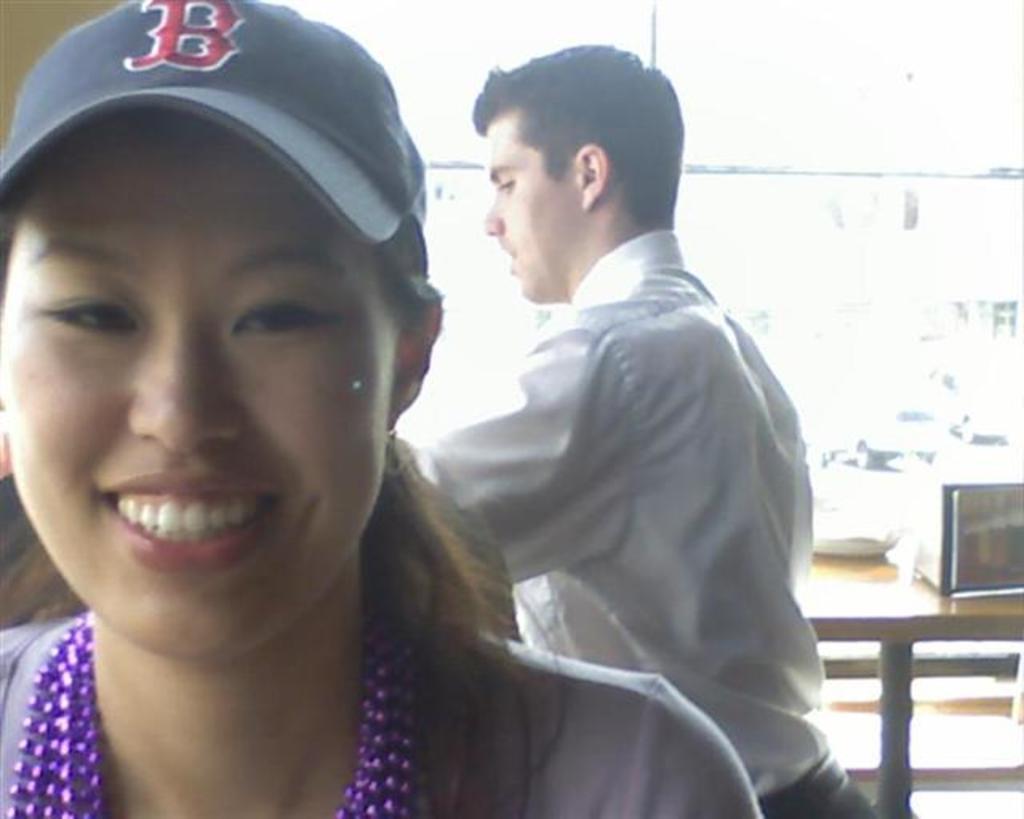What is the letter on the cap?
Your answer should be compact. B. 